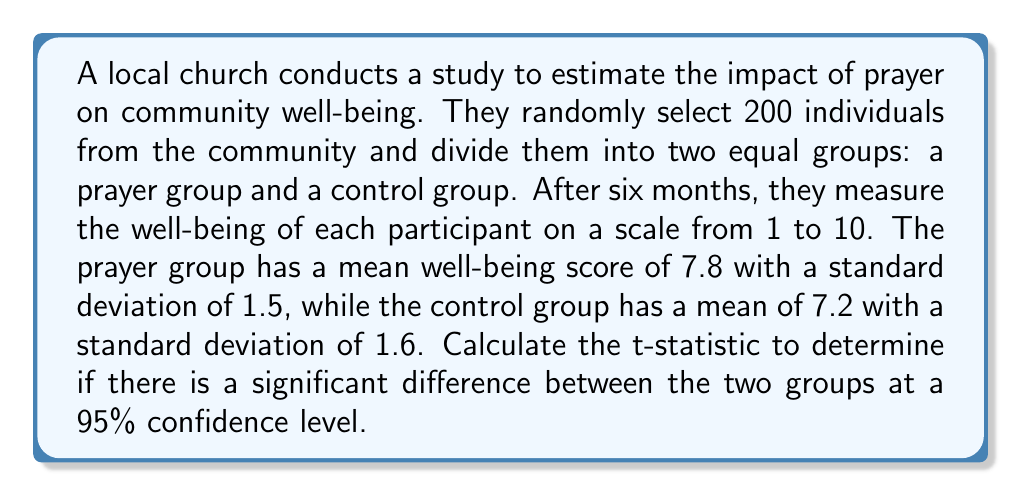Can you solve this math problem? To determine if there is a significant difference between the two groups, we need to calculate the t-statistic and compare it to the critical value for a 95% confidence level.

Step 1: Calculate the pooled standard deviation.
$$s_p = \sqrt{\frac{(n_1 - 1)s_1^2 + (n_2 - 1)s_2^2}{n_1 + n_2 - 2}}$$
Where $n_1 = n_2 = 100$, $s_1 = 1.5$, and $s_2 = 1.6$

$$s_p = \sqrt{\frac{(100 - 1)(1.5)^2 + (100 - 1)(1.6)^2}{100 + 100 - 2}} = \sqrt{\frac{222.75 + 253.44}{198}} = \sqrt{2.4050} = 1.5508$$

Step 2: Calculate the standard error of the difference between means.
$$SE = s_p \sqrt{\frac{1}{n_1} + \frac{1}{n_2}} = 1.5508 \sqrt{\frac{1}{100} + \frac{1}{100}} = 1.5508 \sqrt{0.02} = 0.2192$$

Step 3: Calculate the t-statistic.
$$t = \frac{\bar{x_1} - \bar{x_2}}{SE} = \frac{7.8 - 7.2}{0.2192} = 2.7372$$

Step 4: Determine the critical value for a 95% confidence level with 198 degrees of freedom (df = n1 + n2 - 2 = 198).
The critical value for a two-tailed test at 95% confidence level with 198 df is approximately 1.9720.

Step 5: Compare the calculated t-statistic to the critical value.
Since 2.7372 > 1.9720, we can conclude that there is a significant difference between the two groups at a 95% confidence level.
Answer: $t = 2.7372$ 